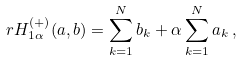Convert formula to latex. <formula><loc_0><loc_0><loc_500><loc_500>\ r H _ { 1 \alpha } ^ { ( + ) } ( a , b ) = \sum _ { k = 1 } ^ { N } b _ { k } + \alpha \sum _ { k = 1 } ^ { N } a _ { k } \, ,</formula> 